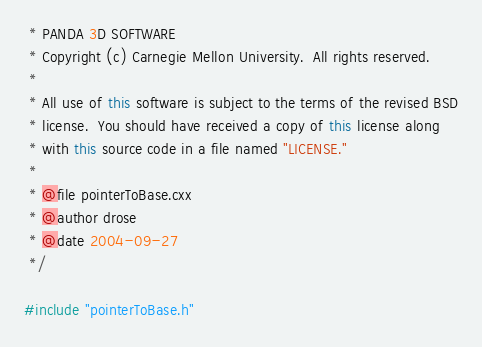Convert code to text. <code><loc_0><loc_0><loc_500><loc_500><_C++_> * PANDA 3D SOFTWARE
 * Copyright (c) Carnegie Mellon University.  All rights reserved.
 *
 * All use of this software is subject to the terms of the revised BSD
 * license.  You should have received a copy of this license along
 * with this source code in a file named "LICENSE."
 *
 * @file pointerToBase.cxx
 * @author drose
 * @date 2004-09-27
 */

#include "pointerToBase.h"
</code> 